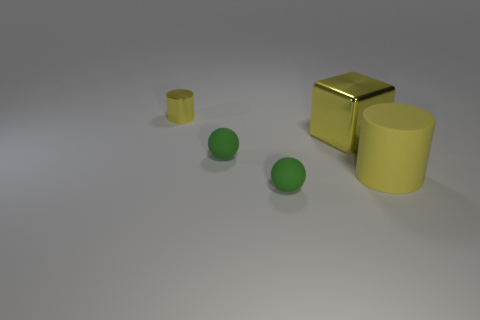Add 3 blue balls. How many objects exist? 8 Subtract all cylinders. How many objects are left? 3 Add 5 large rubber cylinders. How many large rubber cylinders exist? 6 Subtract 0 red balls. How many objects are left? 5 Subtract all matte spheres. Subtract all large things. How many objects are left? 1 Add 5 small yellow shiny cylinders. How many small yellow shiny cylinders are left? 6 